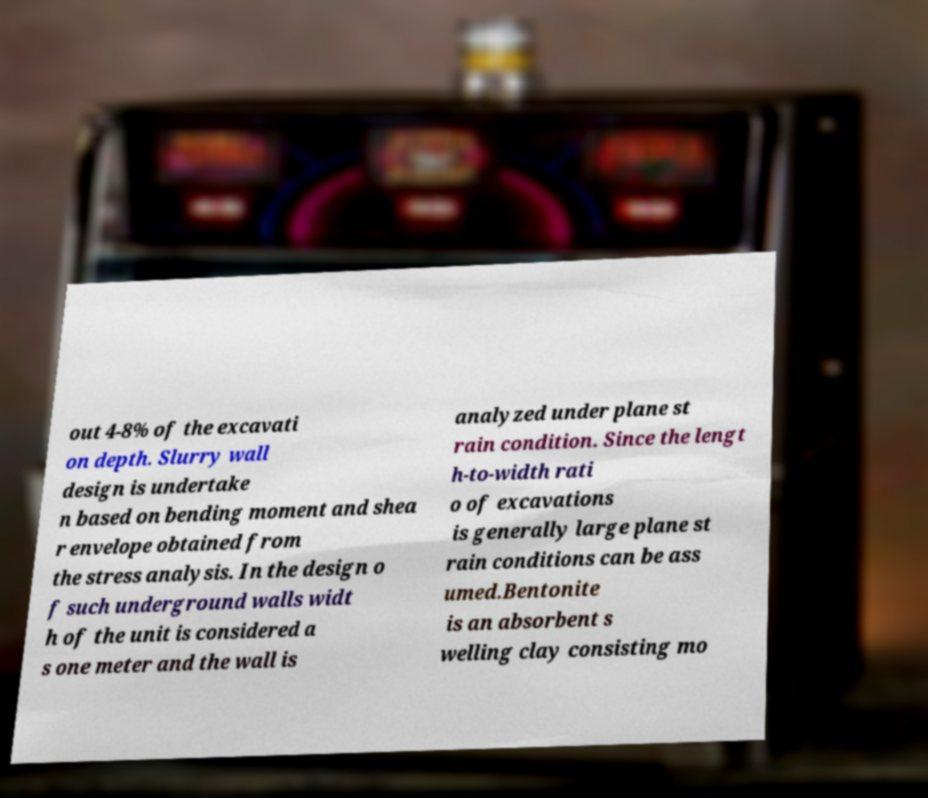Can you read and provide the text displayed in the image?This photo seems to have some interesting text. Can you extract and type it out for me? out 4-8% of the excavati on depth. Slurry wall design is undertake n based on bending moment and shea r envelope obtained from the stress analysis. In the design o f such underground walls widt h of the unit is considered a s one meter and the wall is analyzed under plane st rain condition. Since the lengt h-to-width rati o of excavations is generally large plane st rain conditions can be ass umed.Bentonite is an absorbent s welling clay consisting mo 